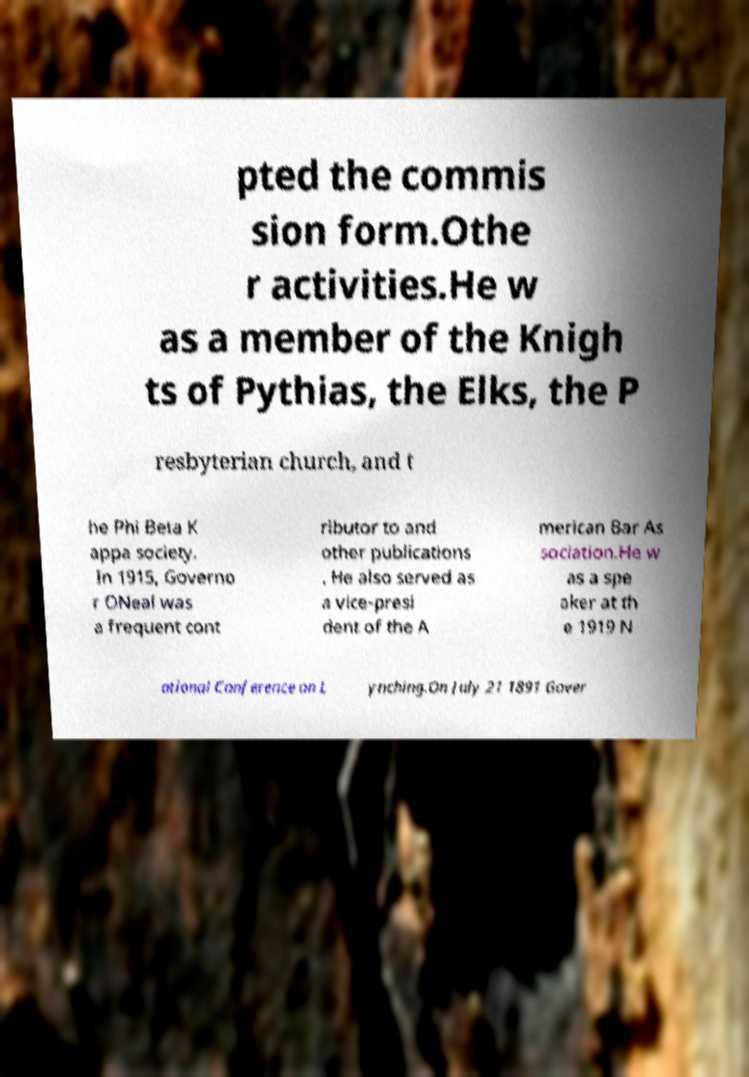Could you assist in decoding the text presented in this image and type it out clearly? pted the commis sion form.Othe r activities.He w as a member of the Knigh ts of Pythias, the Elks, the P resbyterian church, and t he Phi Beta K appa society. In 1915, Governo r ONeal was a frequent cont ributor to and other publications . He also served as a vice-presi dent of the A merican Bar As sociation.He w as a spe aker at th e 1919 N ational Conference on L ynching.On July 21 1891 Gover 